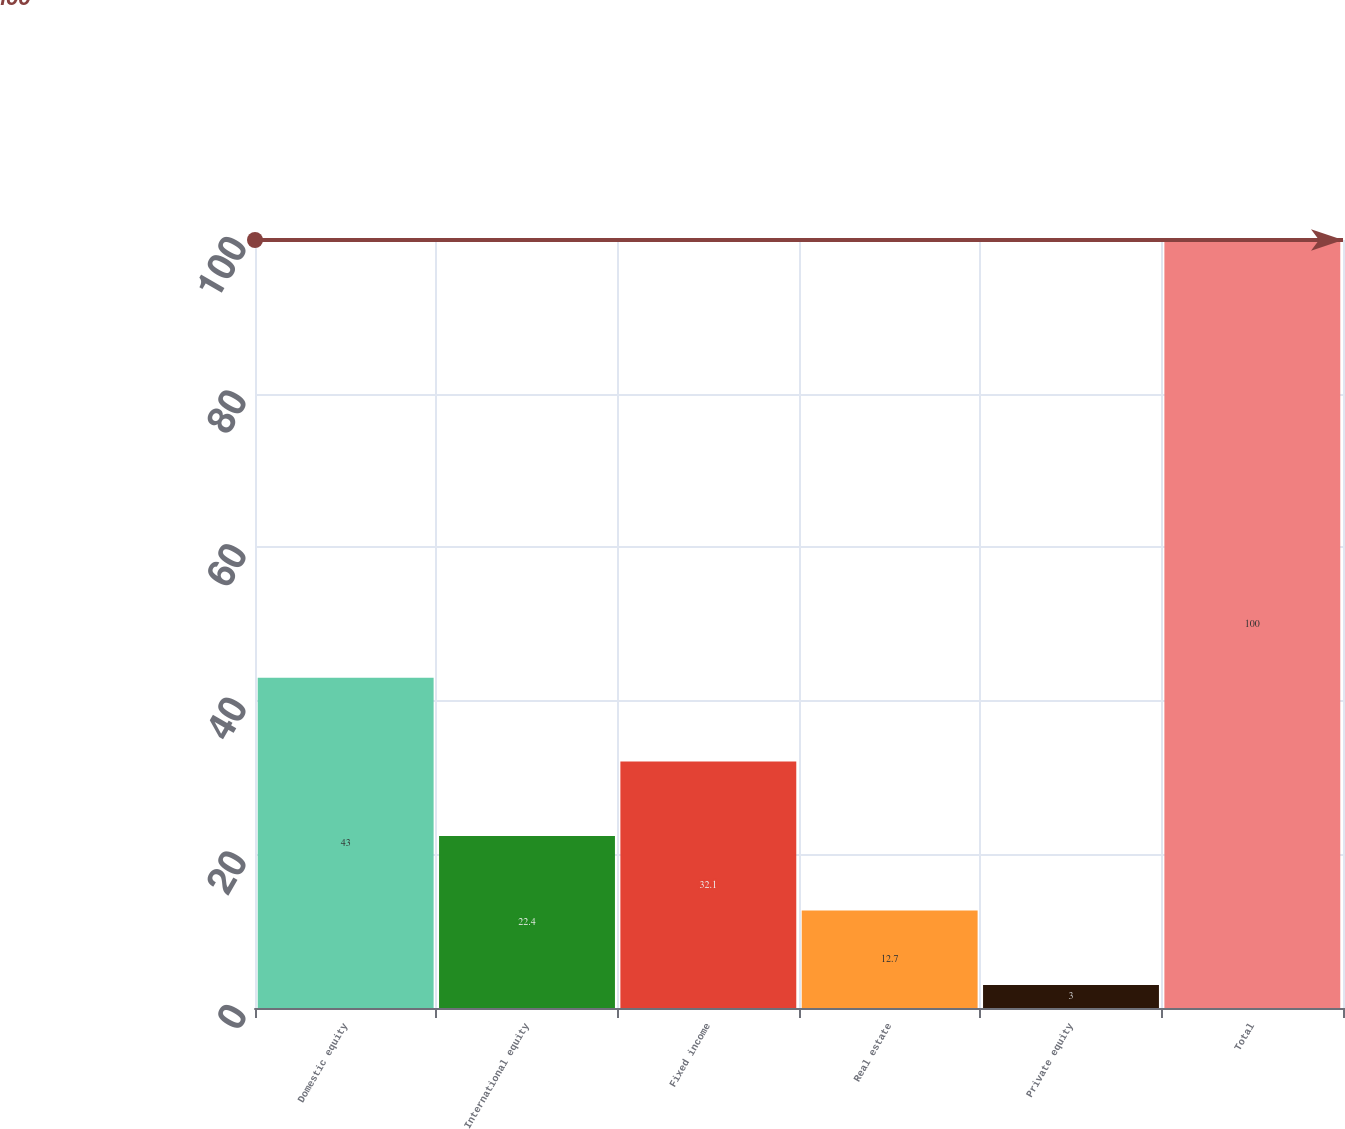Convert chart to OTSL. <chart><loc_0><loc_0><loc_500><loc_500><bar_chart><fcel>Domestic equity<fcel>International equity<fcel>Fixed income<fcel>Real estate<fcel>Private equity<fcel>Total<nl><fcel>43<fcel>22.4<fcel>32.1<fcel>12.7<fcel>3<fcel>100<nl></chart> 